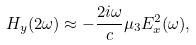Convert formula to latex. <formula><loc_0><loc_0><loc_500><loc_500>H _ { y } ( 2 \omega ) \approx - \frac { 2 i \omega } { c } \mu _ { 3 } E _ { x } ^ { 2 } ( \omega ) ,</formula> 